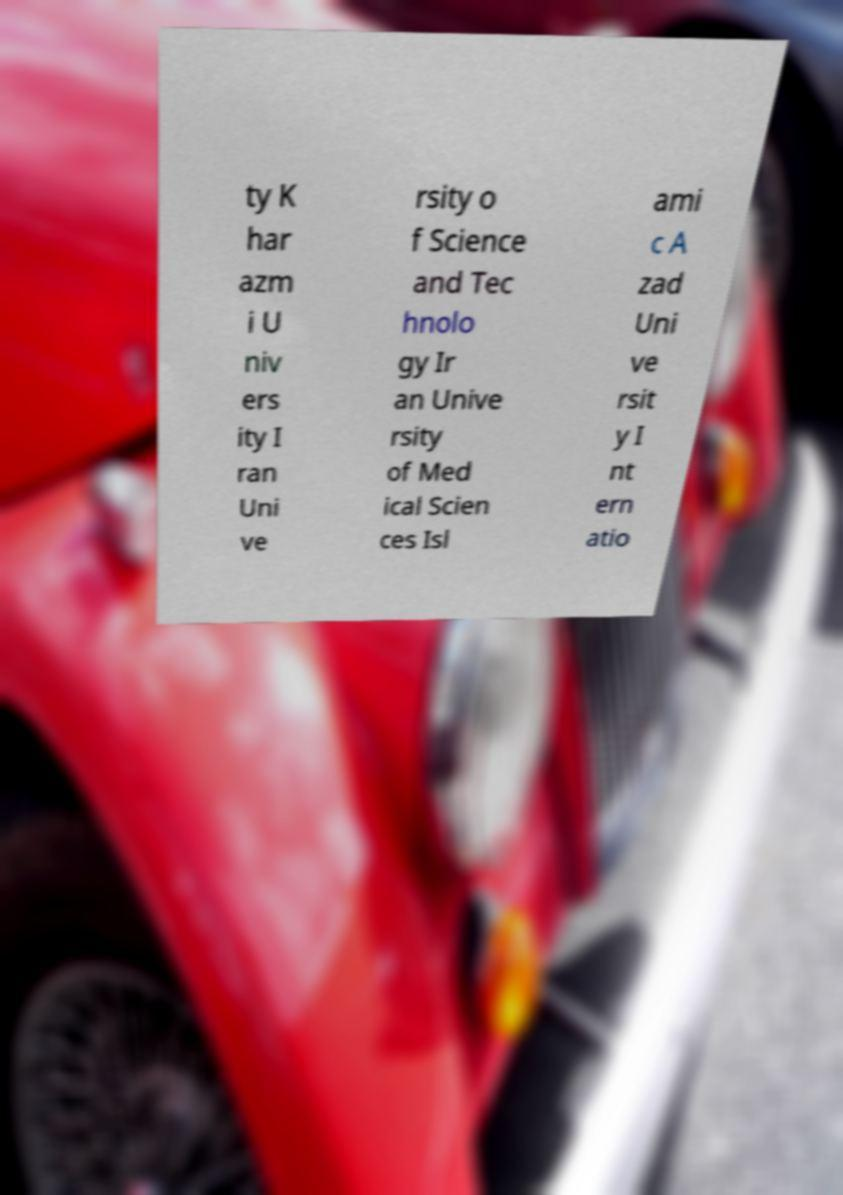Please identify and transcribe the text found in this image. ty K har azm i U niv ers ity I ran Uni ve rsity o f Science and Tec hnolo gy Ir an Unive rsity of Med ical Scien ces Isl ami c A zad Uni ve rsit y I nt ern atio 